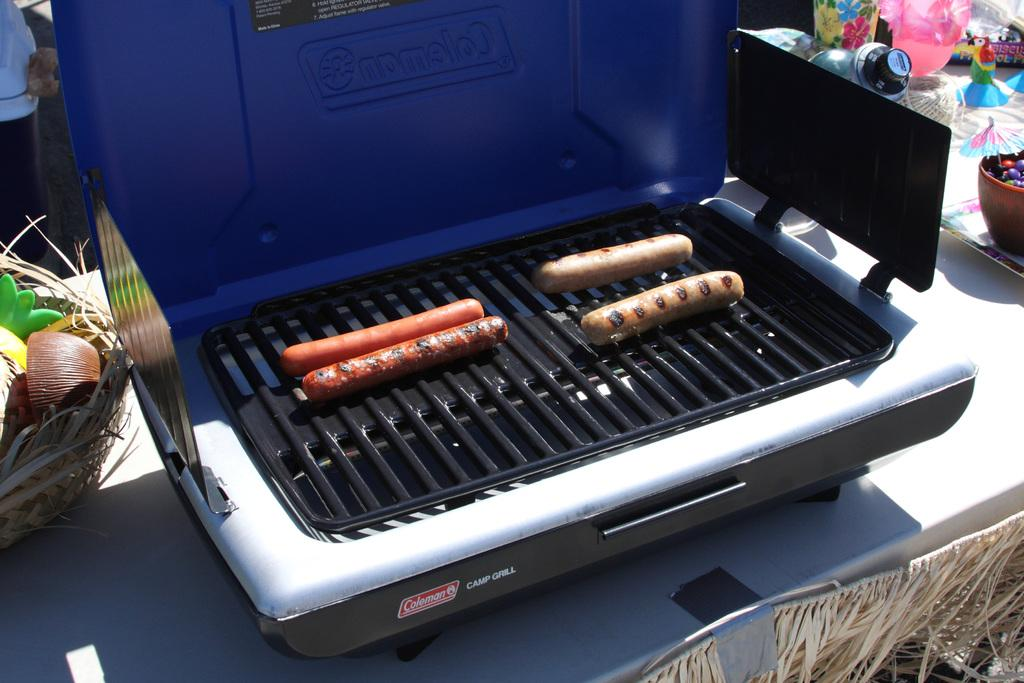<image>
Share a concise interpretation of the image provided. Four hot dogs cook on a Coleman Camp Grill. 